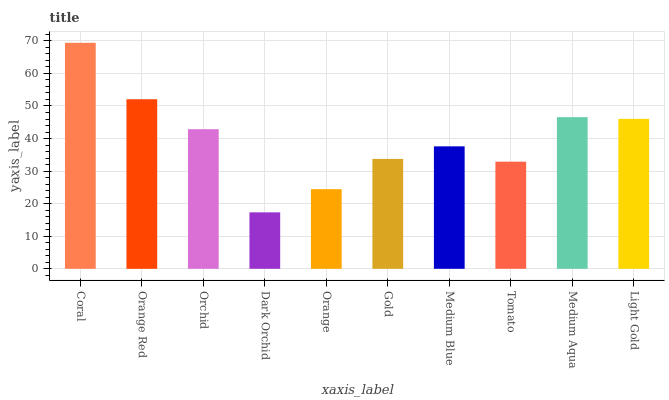Is Orange Red the minimum?
Answer yes or no. No. Is Orange Red the maximum?
Answer yes or no. No. Is Coral greater than Orange Red?
Answer yes or no. Yes. Is Orange Red less than Coral?
Answer yes or no. Yes. Is Orange Red greater than Coral?
Answer yes or no. No. Is Coral less than Orange Red?
Answer yes or no. No. Is Orchid the high median?
Answer yes or no. Yes. Is Medium Blue the low median?
Answer yes or no. Yes. Is Coral the high median?
Answer yes or no. No. Is Dark Orchid the low median?
Answer yes or no. No. 